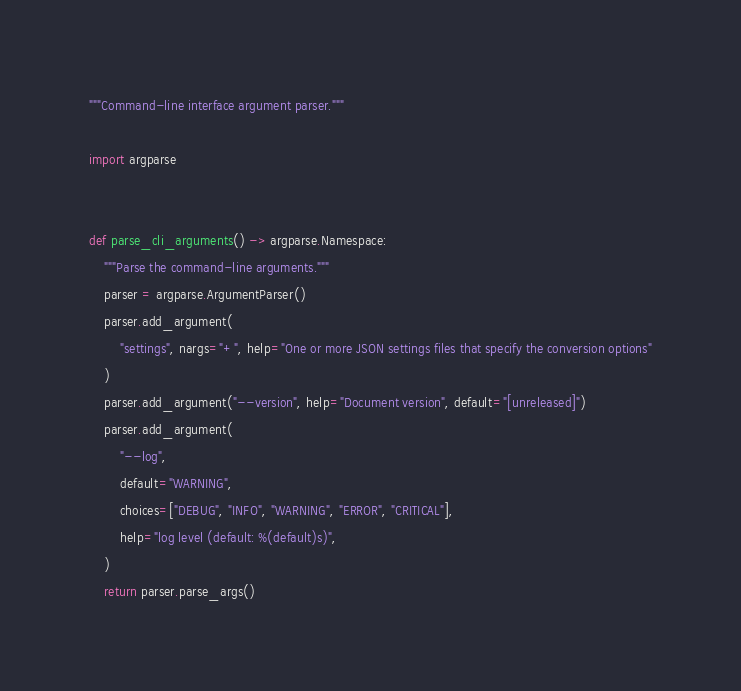<code> <loc_0><loc_0><loc_500><loc_500><_Python_>"""Command-line interface argument parser."""

import argparse


def parse_cli_arguments() -> argparse.Namespace:
    """Parse the command-line arguments."""
    parser = argparse.ArgumentParser()
    parser.add_argument(
        "settings", nargs="+", help="One or more JSON settings files that specify the conversion options"
    )
    parser.add_argument("--version", help="Document version", default="[unreleased]")
    parser.add_argument(
        "--log",
        default="WARNING",
        choices=["DEBUG", "INFO", "WARNING", "ERROR", "CRITICAL"],
        help="log level (default: %(default)s)",
    )
    return parser.parse_args()
</code> 